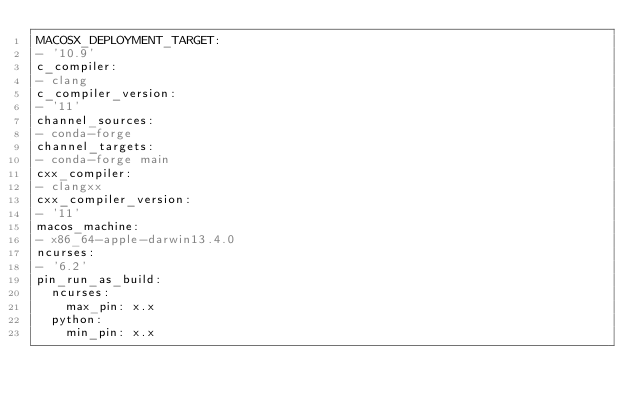Convert code to text. <code><loc_0><loc_0><loc_500><loc_500><_YAML_>MACOSX_DEPLOYMENT_TARGET:
- '10.9'
c_compiler:
- clang
c_compiler_version:
- '11'
channel_sources:
- conda-forge
channel_targets:
- conda-forge main
cxx_compiler:
- clangxx
cxx_compiler_version:
- '11'
macos_machine:
- x86_64-apple-darwin13.4.0
ncurses:
- '6.2'
pin_run_as_build:
  ncurses:
    max_pin: x.x
  python:
    min_pin: x.x</code> 